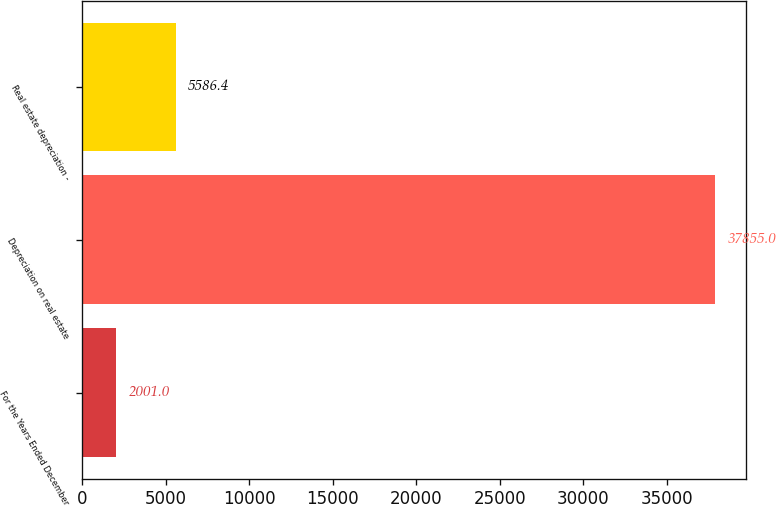Convert chart to OTSL. <chart><loc_0><loc_0><loc_500><loc_500><bar_chart><fcel>For the Years Ended December<fcel>Depreciation on real estate<fcel>Real estate depreciation -<nl><fcel>2001<fcel>37855<fcel>5586.4<nl></chart> 